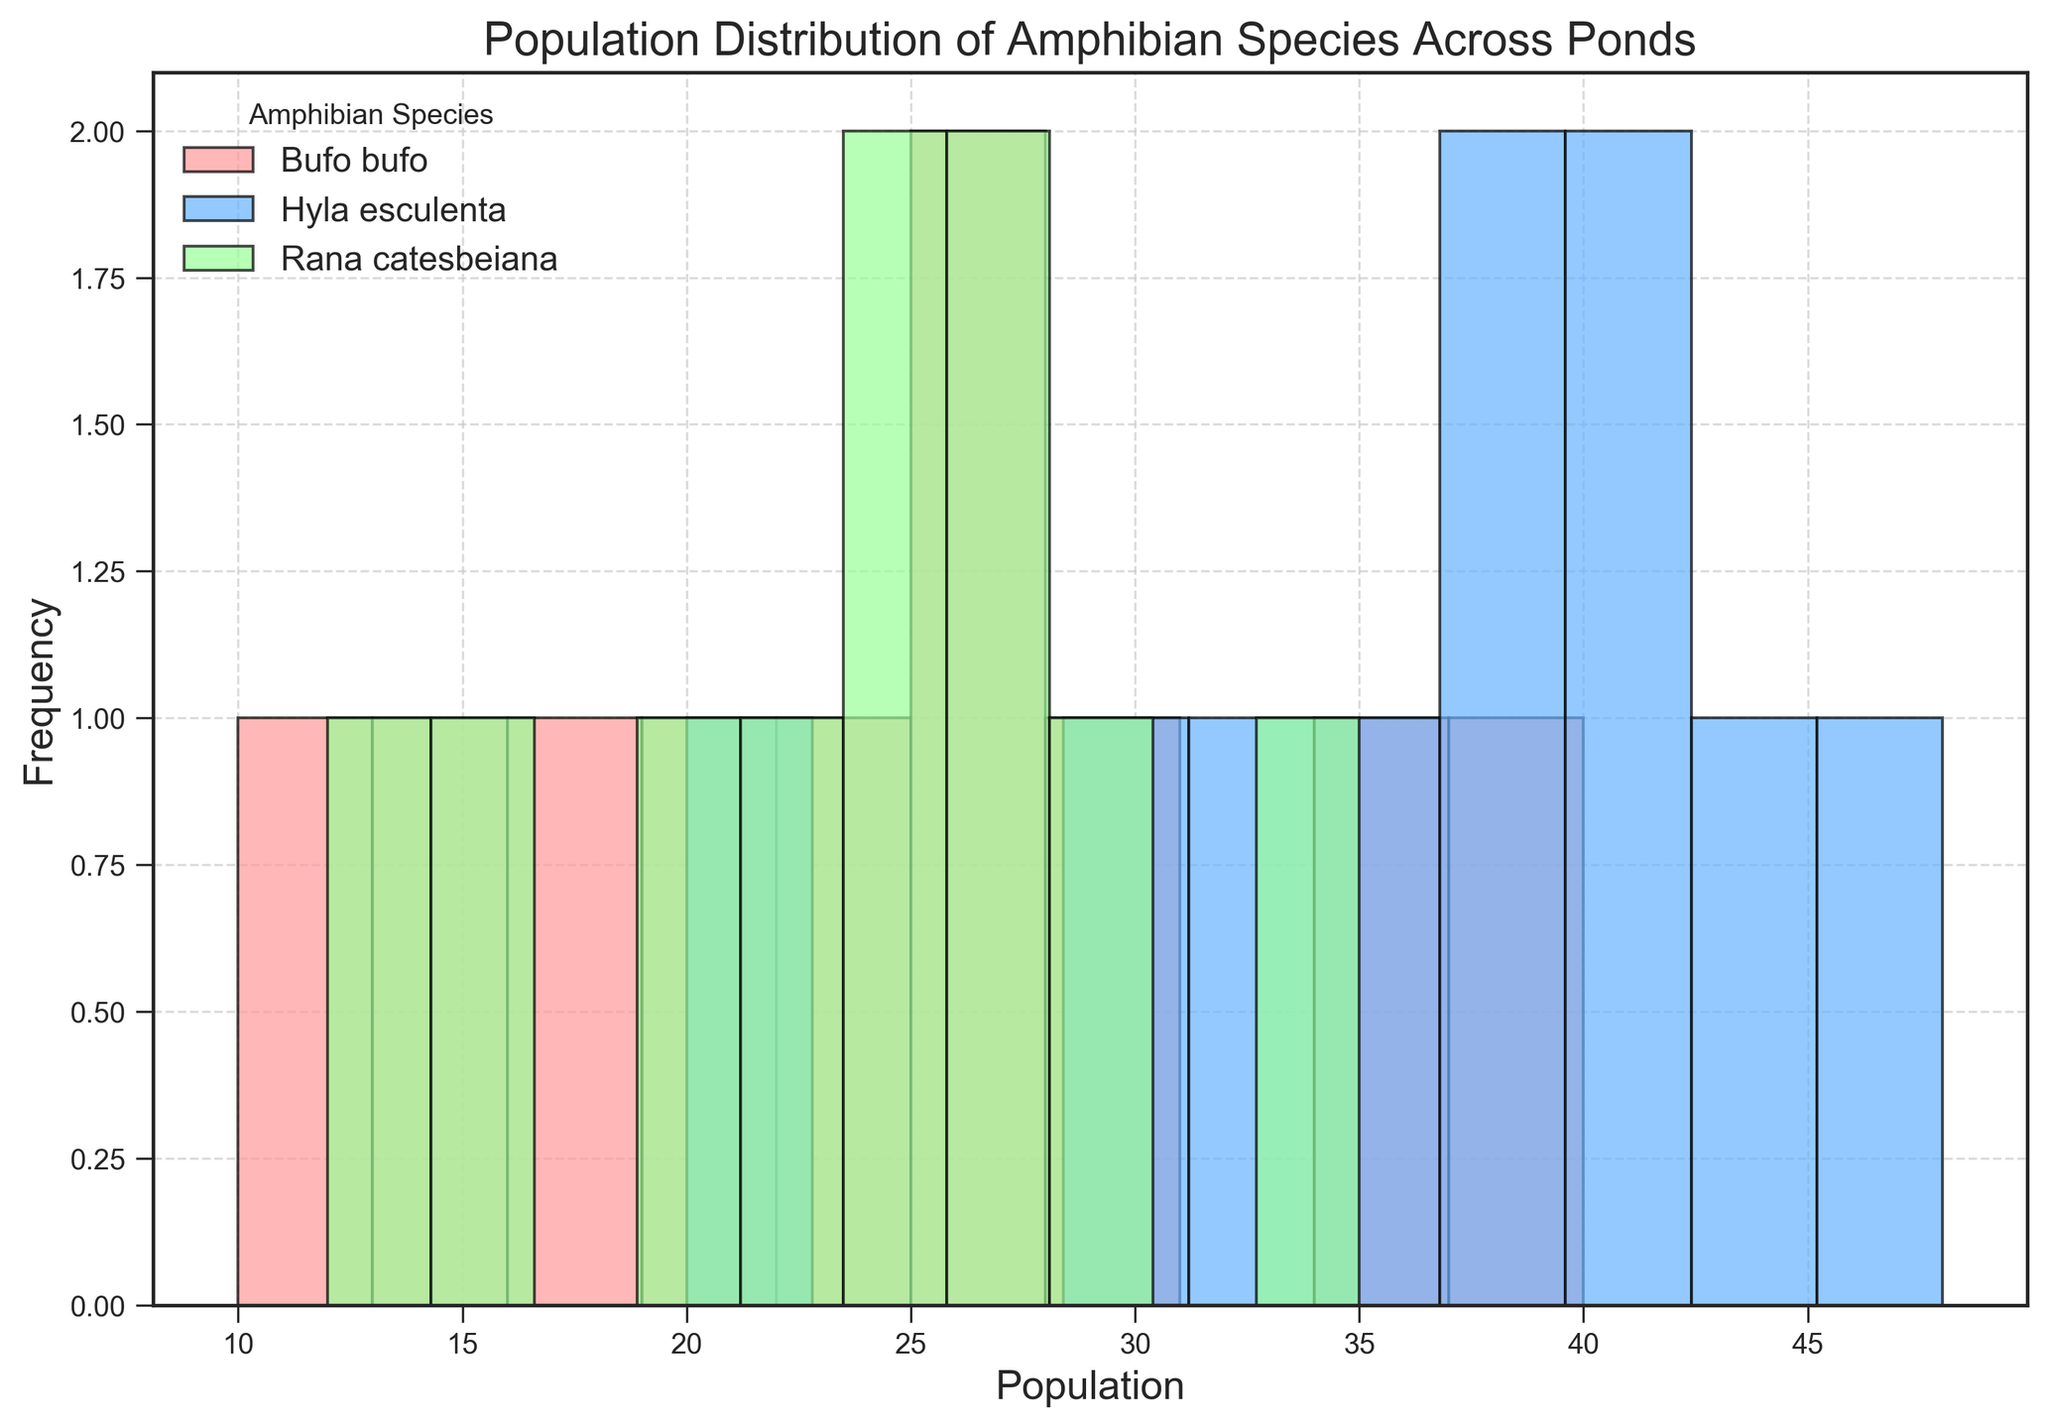what is the dominant color representing the species with the highest overall population in the ponds? The color used for each species is unique in the histogram. By observing the frequency count for each species, we see that Hyla esculenta has the highest overall population and is represented by blue.
Answer: blue Which species has the most frequent population count? By examining the histogram bars, it can be observed that Hyla esculenta has a higher number of ponds with population counts in the upper frequency ranges, indicating it as the most frequently present species.
Answer: Hyla esculenta What’s the average population of Bufo bufo species across all ponds? To find the average, sum the populations of Bufo bufo across all ponds (35 + 15 + 27 + 20 + 22 + 18 + 25 + 30 + 10 + 40 = 242) and divide by the number of ponds (10). The calculation is 242 / 10.
Answer: 24.2 How does the population distribution of Rana catesbeiana compare to Bufo bufo? By comparing the height of the bars, we can see that Rana catesbeiana has a more clustered population in lower ranges, while Bufo bufo has more varied counts, including both low and high populations.
Answer: Bufo bufo has a wider range, Rana catesbeiana is more clustered in lower ranges What is the highest recorded population for Hyla esculenta and how often does it occur? The histogram shows the tallest bar for Hyla esculenta at the population bin around 35-45, with a distinct peak showing that in some ponds it reaches a population close to 48.
Answer: Around 48 with one occurrence What is the most frequent population range for Rana catesbeiana? From observing the histogram, it appears that the tallest bar for Rana catesbeiana occurs in the range of 20-30, indicating it is the most frequent.
Answer: 20-30 Which species has the least variation in population size across different ponds? By analyzing the spread and concentration of the histogram bars, Rana catesbeiana appears to have the least variation in population, being more consistently within a narrow range of counts.
Answer: Rana catesbeiana What is the combined total population for all species in pond 1? Summing the populations of Bufo bufo (35), Hyla esculenta (42), and Rana catesbeiana (25) in pond 1 yields the combined total: 35 + 42 + 25.
Answer: 102 